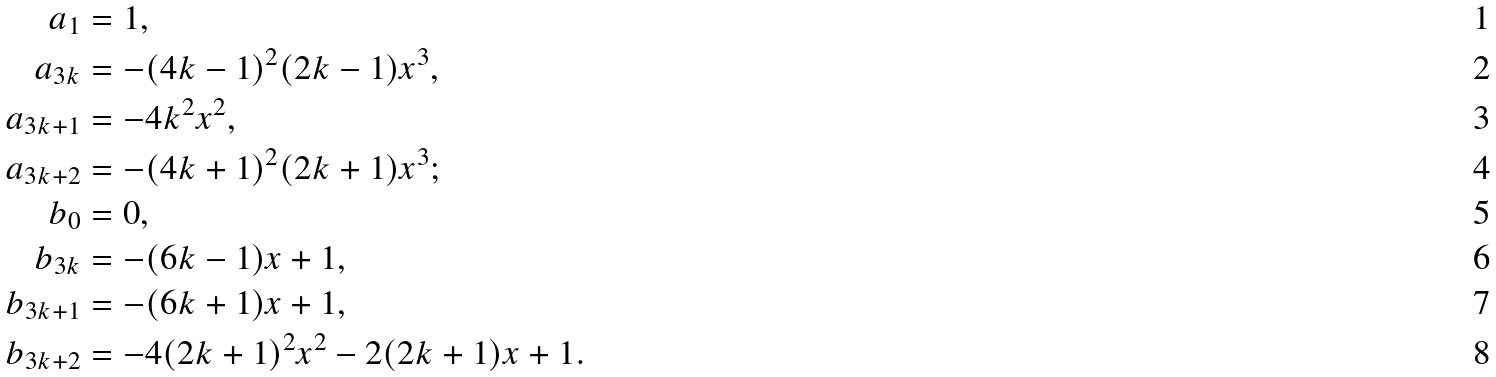<formula> <loc_0><loc_0><loc_500><loc_500>a _ { 1 } & = 1 , \\ a _ { 3 k } & = - ( 4 k - 1 ) ^ { 2 } ( 2 k - 1 ) x ^ { 3 } , \\ a _ { 3 k + 1 } & = - 4 k ^ { 2 } x ^ { 2 } , \\ a _ { 3 k + 2 } & = - ( 4 k + 1 ) ^ { 2 } ( 2 k + 1 ) x ^ { 3 } ; \\ b _ { 0 } & = 0 , \\ b _ { 3 k } & = - ( 6 k - 1 ) x + 1 , \\ b _ { 3 k + 1 } & = - ( 6 k + 1 ) x + 1 , \\ b _ { 3 k + 2 } & = - 4 ( 2 k + 1 ) ^ { 2 } x ^ { 2 } - 2 ( 2 k + 1 ) x + 1 .</formula> 